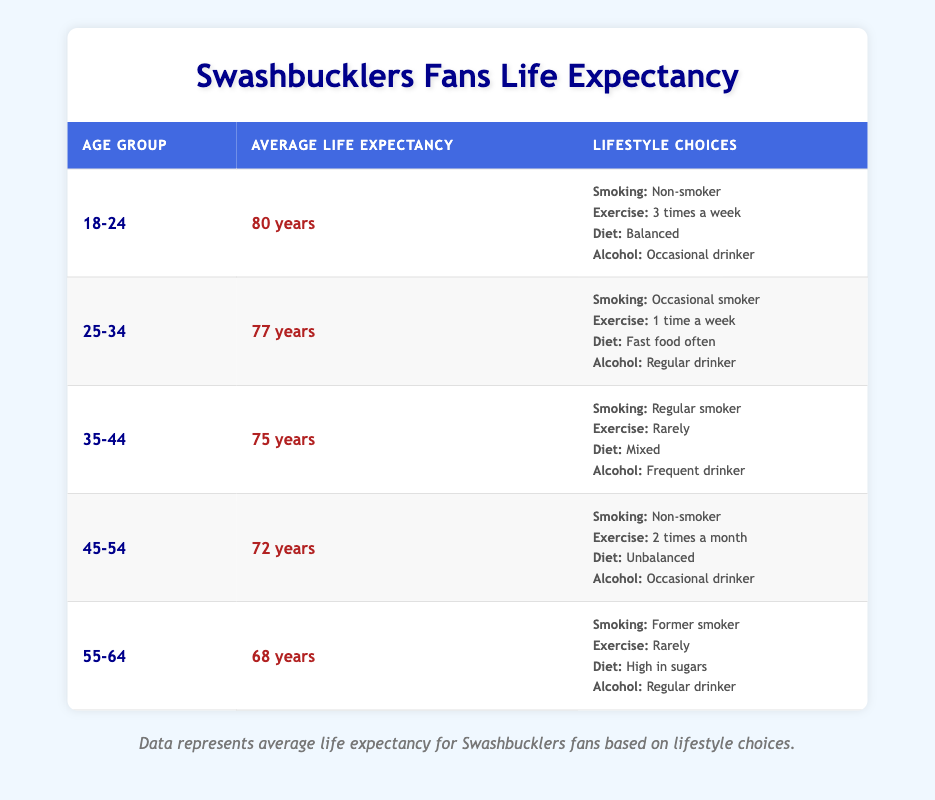What is the average life expectancy for Swashbucklers fans aged 18-24? Referring to the table, the average life expectancy for the age group 18-24 is 80 years.
Answer: 80 years What lifestyle choice is associated with the lowest average life expectancy among Swashbucklers fans? By examining the life expectancy values, the age group 55-64 has the lowest average life expectancy of 68 years, with a lifestyle choice of being a former smoker, exercising rarely, having a high sugar diet, and regular alcohol consumption.
Answer: Former smoker with poor lifestyle choices How does the average life expectancy for Swashbucklers fans decline from age group 25-34 to 45-54? The average life expectancy for 25-34 is 77 years, and for 45-54 it is 72 years. The decline is calculated as 77 - 72 = 5 years.
Answer: 5 years Is the average life expectancy higher for non-smokers compared to regular smokers among Swashbucklers fans? Non-smokers in the age groups 18-24 (80 years) and 45-54 (72 years) have higher average life expectancy compared to regular smokers in the 35-44 age group (75 years). Thus, yes, non-smokers have higher average life expectancy.
Answer: Yes Calculate the average life expectancy for Swashbucklers fans aged 35-44 and 55-64. The average life expectancy for 35-44 is 75 years and for 55-64 is 68 years. The average of these two age groups is (75 + 68) / 2 = 71.5 years.
Answer: 71.5 years What is the relationship between exercise frequency and average life expectancy in the 25-34 age group? In the 25-34 age group, the exercise frequency is 1 time a week with an average life expectancy of 77 years. Since this is lower compared to the earlier age group with 3 times a week and higher life expectancy, less frequent exercise correlates with lower life expectancy.
Answer: Less frequent exercise correlates with lower life expectancy Was there any age group where alcohol consumption is noted as a "frequent drinker" with an average life expectancy above 70 years? From the table, the 35-44 age group with frequent drinkers has an average life expectancy of 75 years, which is above 70 years. So, the answer is yes.
Answer: Yes What is the change in average life expectancy from the age group 18-24 to 55-64? The average life expectancy for 18-24 is 80 years and for 55-64 is 68 years. The change is 80 - 68 = 12 years.
Answer: 12 years 